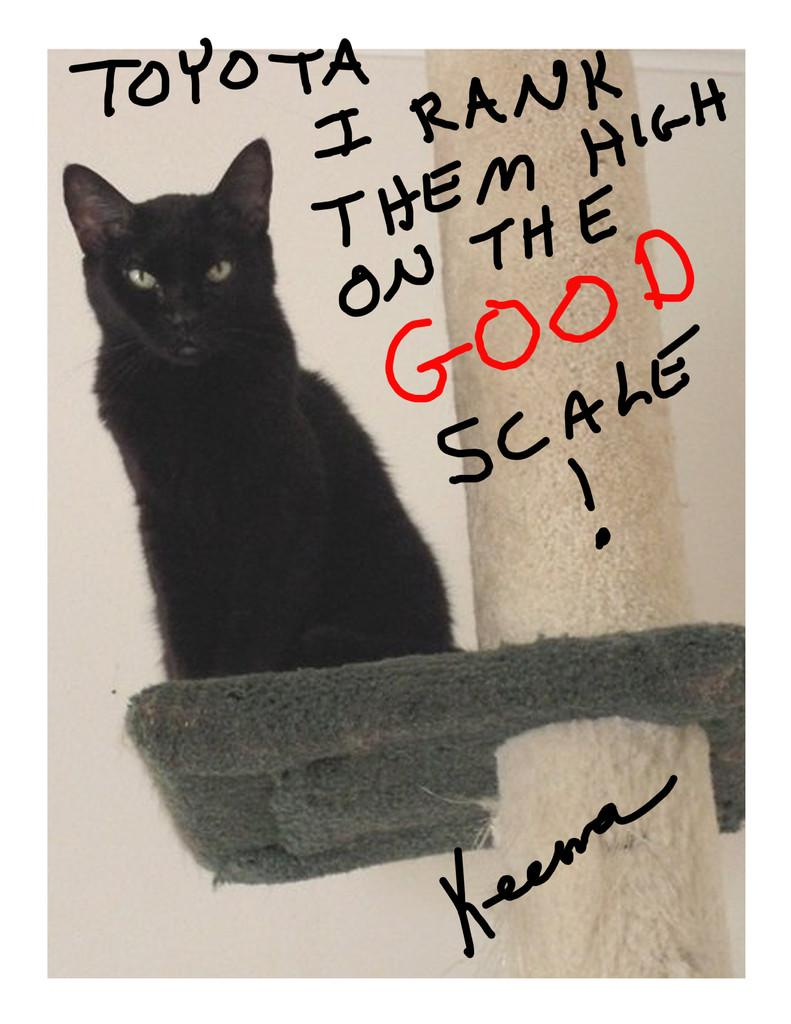What is the main subject in the center of the image? There is a cat in the center of the image. What can be seen on the right side of the image? There is a pole on the right side of the image. What is visible in the background of the image? There is a wall in the background of the image. What is written on the wall? Text is written on the wall. What type of wire is being used for the meeting in the image? There is no meeting or wire present in the image; it features a cat and a pole. What kind of suit is the cat wearing in the image? Cats do not wear suits, and there is no suit present in the image. 